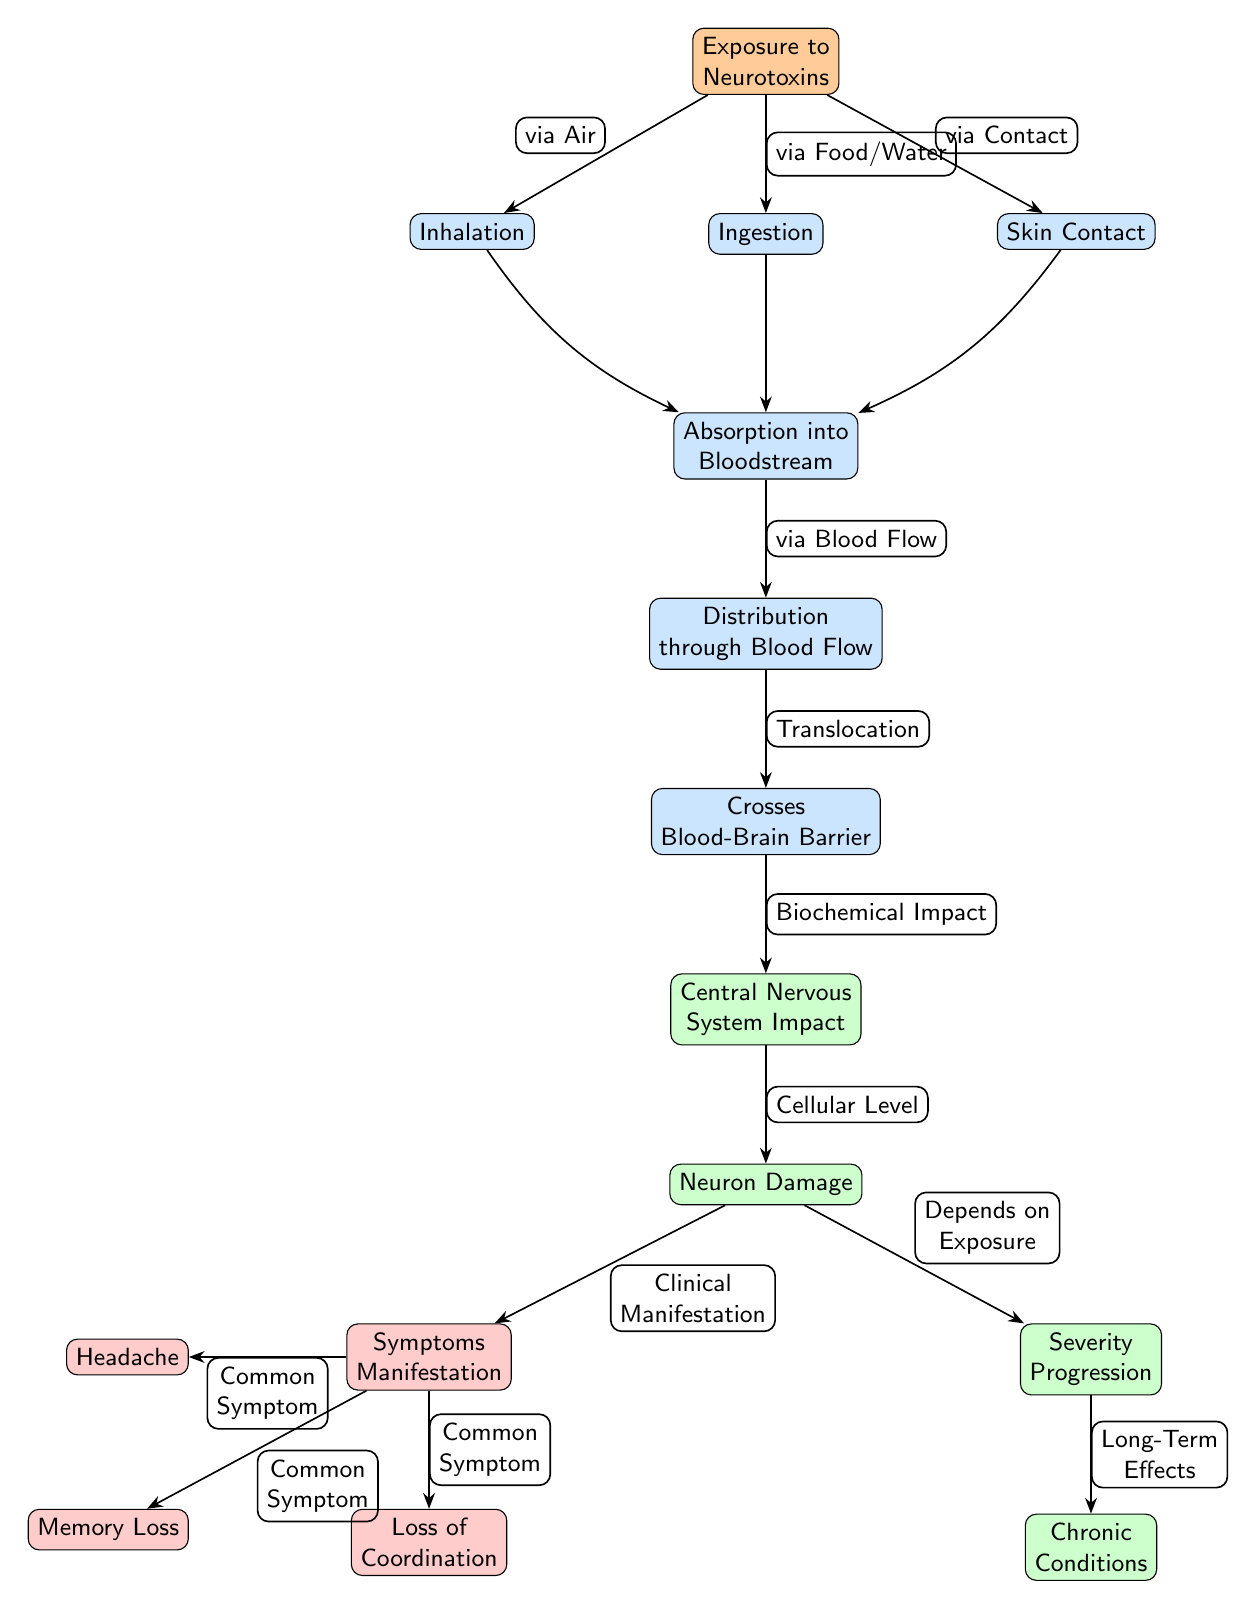What is the first node in the diagram? The first node in the diagram is "Exposure to Neurotoxins," which is positioned at the top and serves as the starting point for the pathways illustrated in the diagram.
Answer: Exposure to Neurotoxins How many pathways of exposure are represented in the diagram? There are three pathways of exposure illustrated in the diagram: Inhalation, Ingestion, and Skin Contact, all originating from the Exposure to Neurotoxins node.
Answer: 3 What node directly follows "Absorption into Bloodstream"? The node directly following "Absorption into Bloodstream" is "Distribution through Blood Flow," which shows the next step in the journey of neurotoxins after absorption.
Answer: Distribution through Blood Flow What type of impact is depicted after "Crosses Blood-Brain Barrier"? The impact depicted after "Crosses Blood-Brain Barrier" is "Central Nervous System Impact," indicating that neurotoxins affecting the CNS occur at this stage.
Answer: Central Nervous System Impact Which symptoms are classified as common symptoms in the diagram? The common symptoms listed are "Headache," "Memory Loss," and "Loss of Coordination," which are shown emanating from the Symptoms Manifestation node.
Answer: Headache, Memory Loss, Loss of Coordination What node represents the final outcome related to exposure severity? The node that represents the final outcome related to exposure severity is "Chronic Conditions," which signifies long-term effects of neurotoxin exposure and follows the Severity Progression.
Answer: Chronic Conditions How is "Inhalation" linked to "Absorption into Bloodstream"? "Inhalation" is linked to "Absorption into Bloodstream" through a bend in the path indicating that exposure via inhalation leads to neurological impacts by entering the bloodstream.
Answer: via Blood Flow Which pathway directly impacts neuron damage? The pathway that directly impacts neuron damage is from "Crosses Blood-Brain Barrier" to "Neuron Damage," illustrating that crossing this barrier is crucial for toxicity to affect neurons.
Answer: Crosses Blood-Brain Barrier What factor influences the "Severity Progression"? The factor influencing the "Severity Progression" is "Depends on Exposure," which indicates that the severity of symptoms depends on the level and nature of exposure to neurotoxins.
Answer: Depends on Exposure 